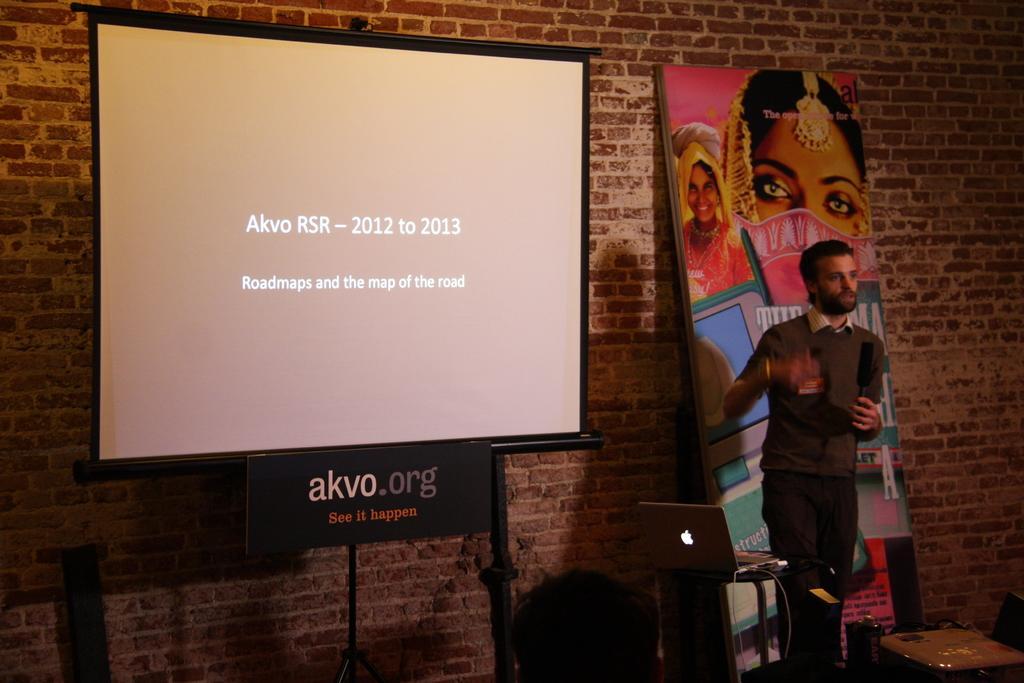Describe this image in one or two sentences. In this image we can see a person speaking into a mic. There is a laptop in the image. There is a projector screen in the image. There are few objects in the image. 